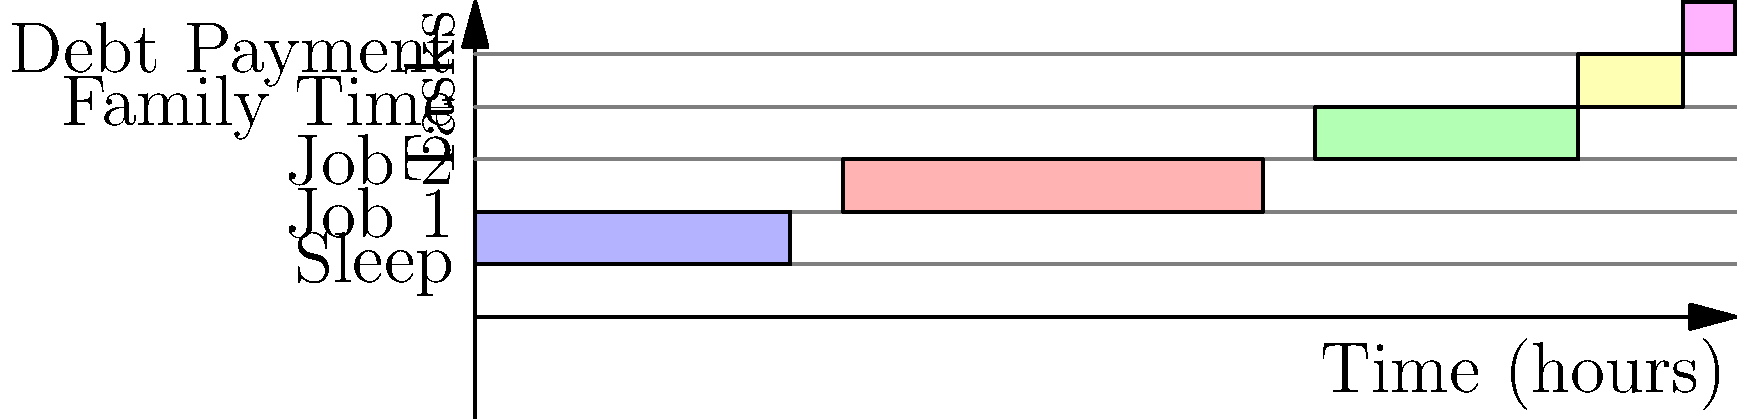As a single parent with two jobs, you're trying to optimize your daily schedule. Given the timeline diagram above, how many total hours are allocated for work (Job 1 and Job 2 combined) in this 24-hour period? To find the total hours allocated for work, we need to:

1. Identify the time blocks for Job 1 and Job 2:
   - Job 1: 7:00 to 15:00 (8 hours)
   - Job 2: 16:00 to 21:00 (5 hours)

2. Calculate the duration of each job:
   - Job 1 duration: $15 - 7 = 8$ hours
   - Job 2 duration: $21 - 16 = 5$ hours

3. Sum up the total work hours:
   Total work hours = Job 1 duration + Job 2 duration
   $= 8 + 5 = 13$ hours

Therefore, the total number of hours allocated for work (Job 1 and Job 2 combined) in this 24-hour period is 13 hours.
Answer: 13 hours 